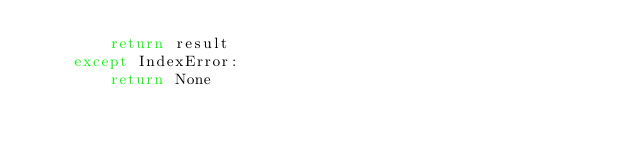Convert code to text. <code><loc_0><loc_0><loc_500><loc_500><_Python_>        return result
    except IndexError:
        return None
</code> 